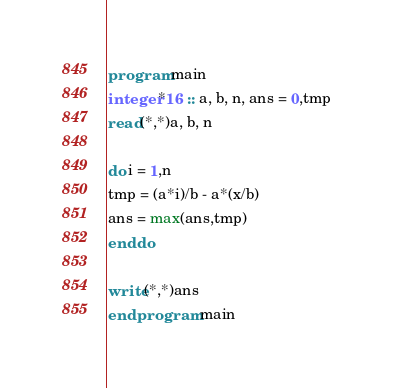<code> <loc_0><loc_0><loc_500><loc_500><_FORTRAN_>program main
integer*16 :: a, b, n, ans = 0,tmp
read(*,*)a, b, n

do i = 1,n
tmp = (a*i)/b - a*(x/b)
ans = max(ans,tmp)
end do

write(*,*)ans
end program main</code> 